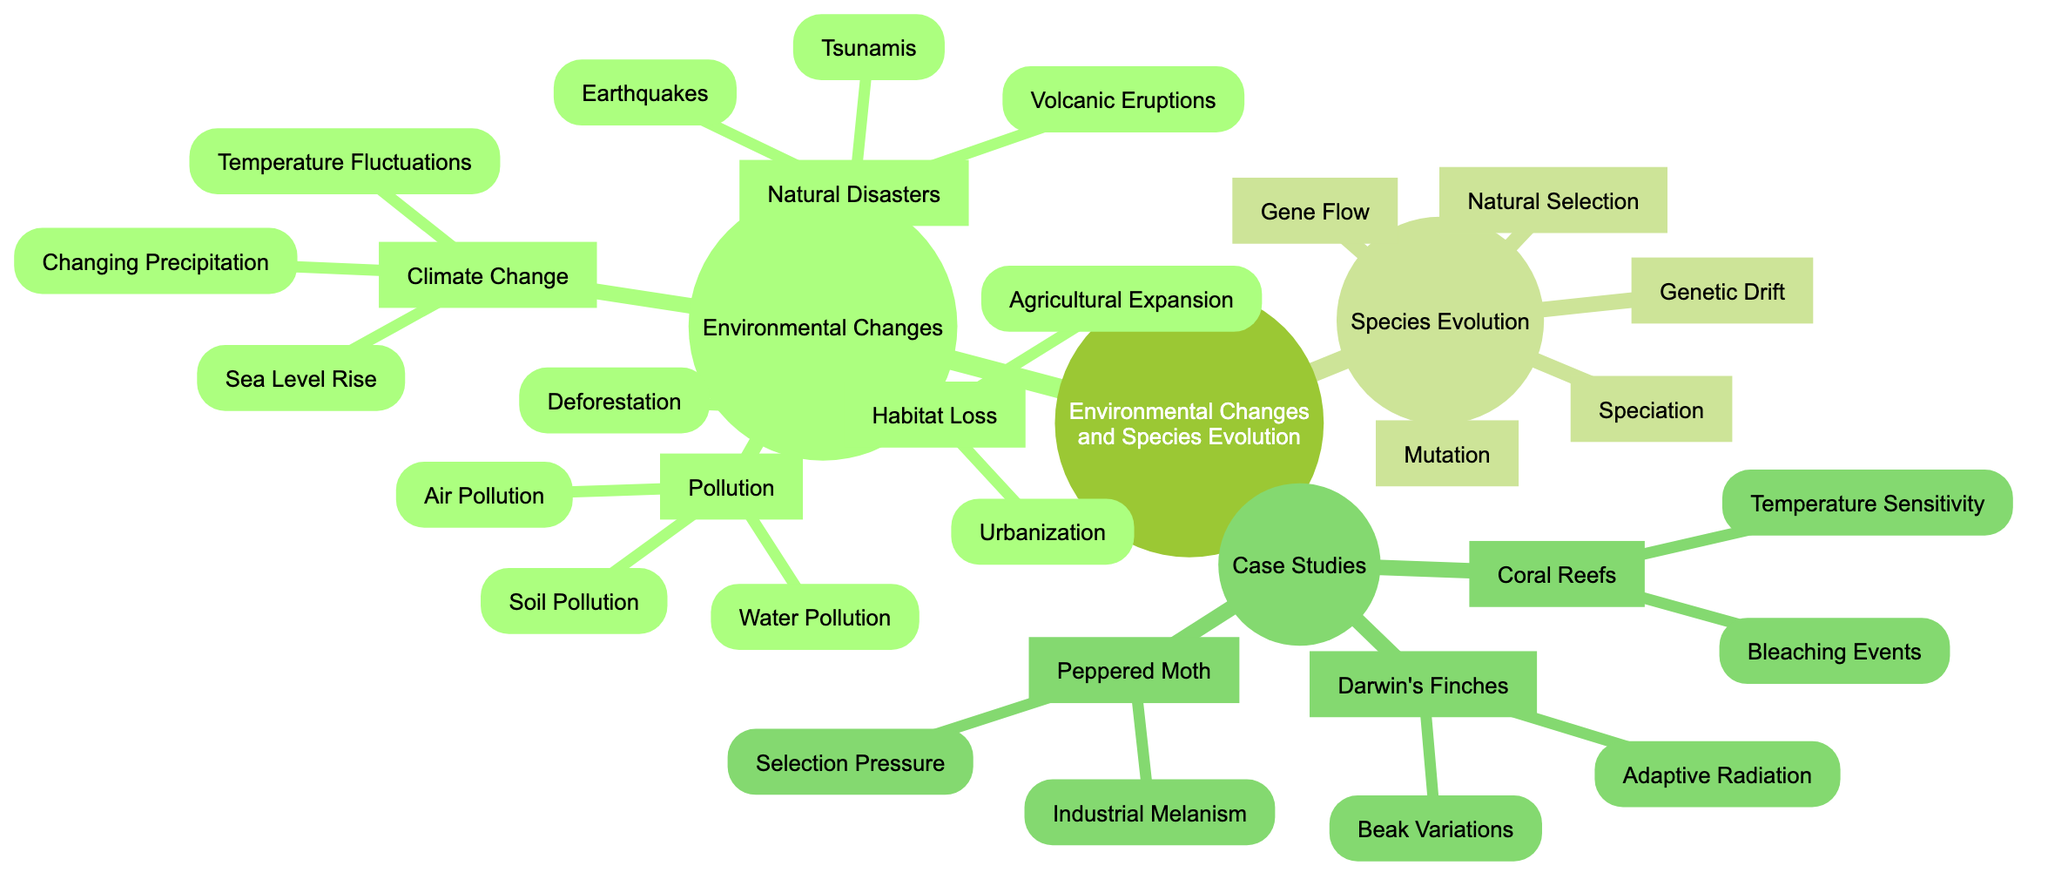What are the three main categories of environmental changes depicted in the diagram? The diagram directly lists three main branches under "Environmental Changes": Climate Change, Habitat Loss, and Pollution. Each of these categories encompasses various specific factors affecting species evolution.
Answer: Climate Change, Habitat Loss, Pollution How many children nodes does the category "Natural Disasters" have? In the diagram, "Natural Disasters" has three children nodes: Earthquakes, Volcanic Eruptions, and Tsunamis. Each represents a type of natural disaster that can influence species evolution.
Answer: 3 Which specific environmental change is associated with deforestation? Deforestation is a direct child node of the "Habitat Loss" category, indicating it is one type of habitat loss that can lead to changes in species evolution.
Answer: Habitat Loss Name one of the case studies provided in the diagram that exemplifies adaptation in species. The diagram includes "Darwin's Finches" as a case study that illustrates adaptive radiation and variations in beak shapes, showcasing how species adapt based on environmental factors.
Answer: Darwin's Finches What evolutionary mechanism is highlighted in the case study of the Peppered Moth? The "Peppered Moth" case study highlights "Industrial Melanism," which describes how environmental changes, such as pollution, can affect the coloration and survival of moths through natural selection.
Answer: Industrial Melanism Which environmental factor might directly influence temperature sensitivity in coral reefs? The category "Climate Change" connects to "Temperature Sensitivity," indicating that changes in climate, particularly rising temperatures, directly affect how sensitive coral reefs are to environmental changes.
Answer: Temperature Sensitivity How does gene flow relate to species evolution according to the concept map? Gene flow is listed under "Species Evolution," suggesting it is one of the mechanisms (along with natural selection, mutation, and others) that affect how species change and adapt over time in response to environmental changes.
Answer: Species Evolution Identify two types of pollution mentioned in the diagram. The diagram specifies three types under "Pollution": Air Pollution, Water Pollution, and Soil Pollution, all of which can have significant impacts on species and ecosystems.
Answer: Air Pollution, Water Pollution What kind of fluctuations are part of climate change influences in the diagram? The diagram lists "Temperature Fluctuations" as a specific child of "Climate Change," indicating that these fluctuations are one way climate change impacts species evolution.
Answer: Temperature Fluctuations 